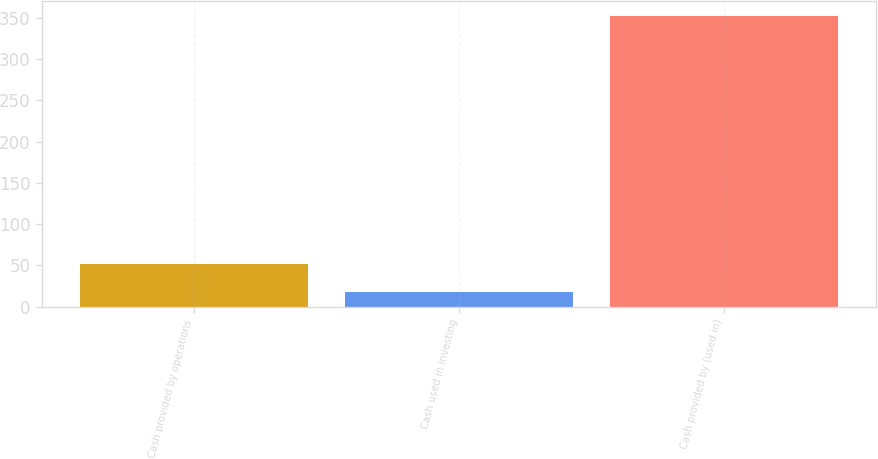Convert chart to OTSL. <chart><loc_0><loc_0><loc_500><loc_500><bar_chart><fcel>Cash provided by operations<fcel>Cash used in investing<fcel>Cash provided by (used in)<nl><fcel>51.5<fcel>18<fcel>353<nl></chart> 